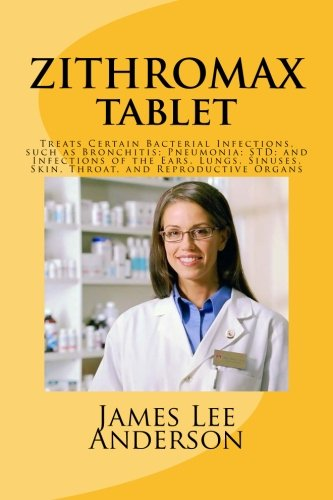What is the genre of this book? Although classified under 'Health, Fitness & Dieting,' a more precise genre for this book would be 'Medical Reference' or 'Pharmacology' given its specific focus on a medication and its uses. 